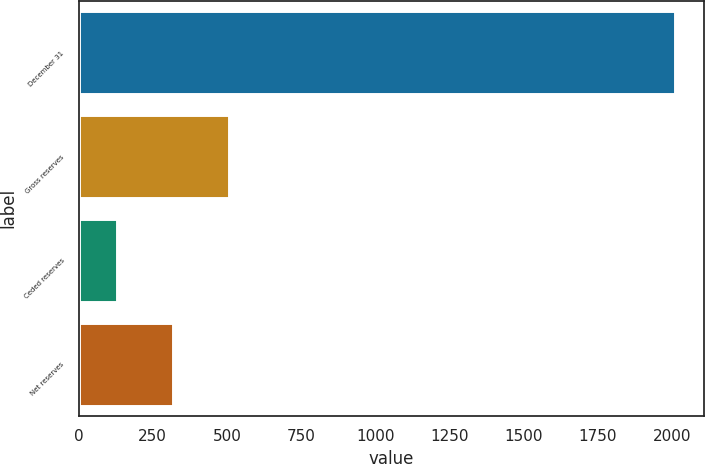Convert chart. <chart><loc_0><loc_0><loc_500><loc_500><bar_chart><fcel>December 31<fcel>Gross reserves<fcel>Ceded reserves<fcel>Net reserves<nl><fcel>2008<fcel>505.6<fcel>130<fcel>317.8<nl></chart> 